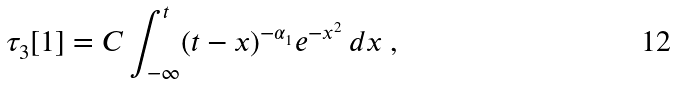Convert formula to latex. <formula><loc_0><loc_0><loc_500><loc_500>\tau _ { 3 } [ 1 ] = C \int _ { - \infty } ^ { t } ( t - x ) ^ { - \alpha _ { 1 } } e ^ { - x ^ { 2 } } \, d x \ ,</formula> 